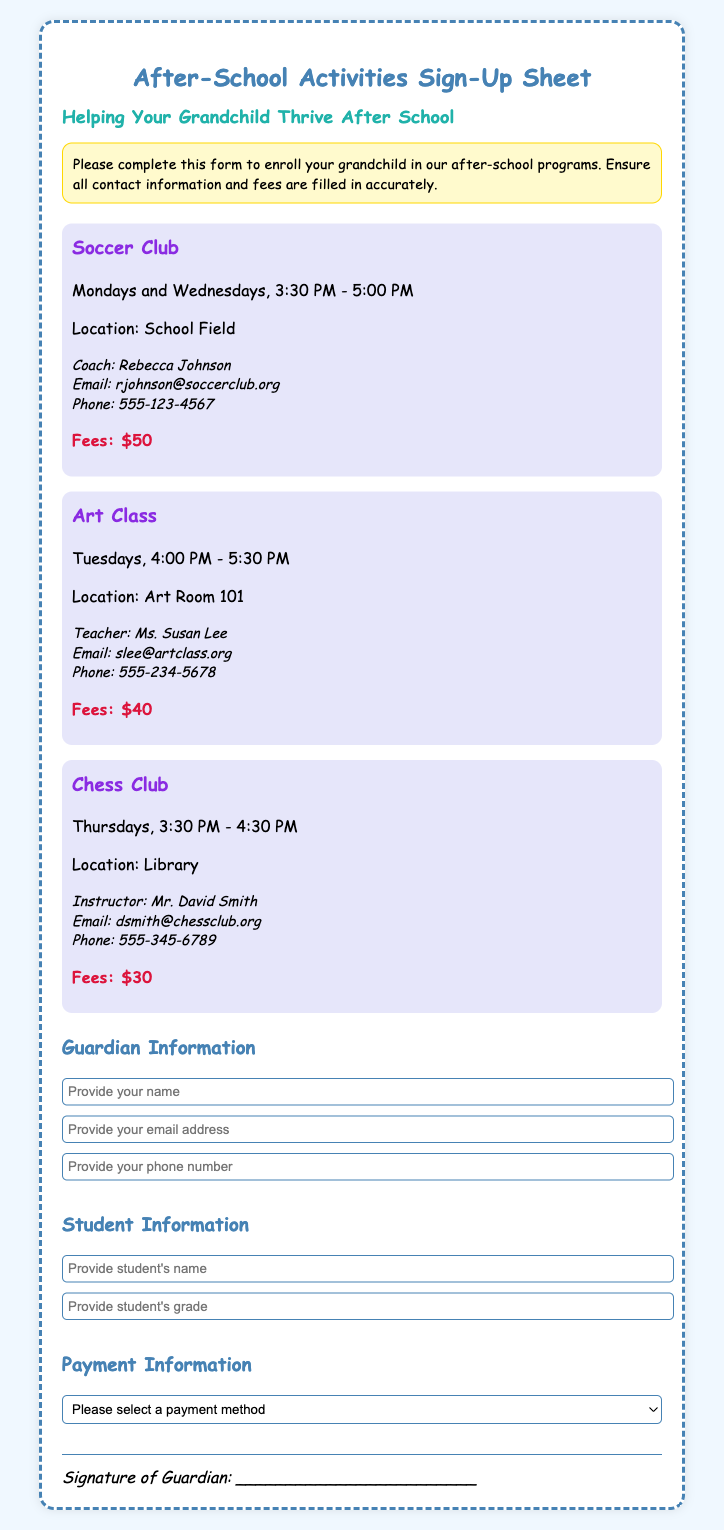What is the title of the document? The title, as seen at the top of the document, indicates the main purpose or subject matter.
Answer: After-School Activities Sign-Up Sheet Who is the coach for the Soccer Club? This is specific information about the personnel involved in one of the activities listed.
Answer: Rebecca Johnson What are the days and times for the Art Class? This requires retrieving specific details regarding the schedule of one of the activities.
Answer: Tuesdays, 4:00 PM - 5:30 PM What is the fee for the Chess Club? This looks for specific financial information related to one of the programs offered.
Answer: $30 What is one method of payment listed on the sign-up sheet? This question checks the available options for fee payment in the document.
Answer: Cash Which location is specified for the Soccer Club? This asks for location details relevant to one of the activities listed.
Answer: School Field How many activities are mentioned in the document? This requires counting the activities listed within the sign-up sheet to derive a total.
Answer: 3 What is the required information for the Guardian section? This question assesses the information gathered under a specific section of the form.
Answer: Name, email address, phone number What is the required document type for the sign-up? This focuses on the purpose of this document and what action it facilitates.
Answer: Sign-Up Sheet 